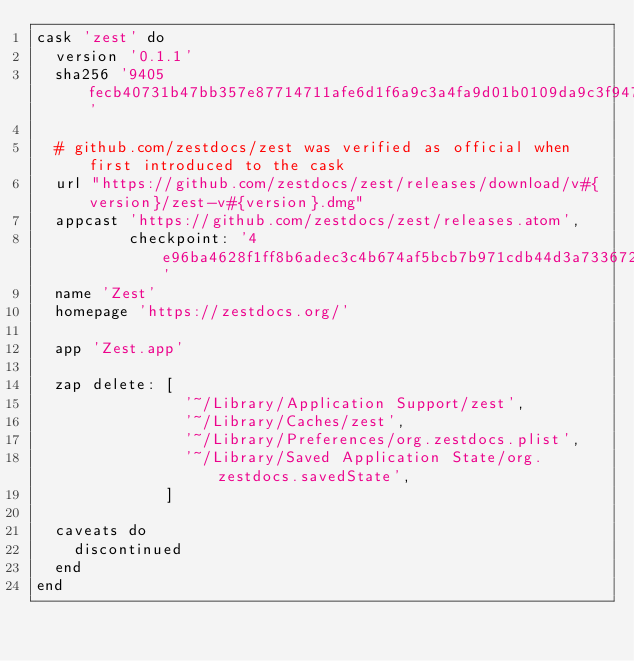Convert code to text. <code><loc_0><loc_0><loc_500><loc_500><_Ruby_>cask 'zest' do
  version '0.1.1'
  sha256 '9405fecb40731b47bb357e87714711afe6d1f6a9c3a4fa9d01b0109da9c3f947'

  # github.com/zestdocs/zest was verified as official when first introduced to the cask
  url "https://github.com/zestdocs/zest/releases/download/v#{version}/zest-v#{version}.dmg"
  appcast 'https://github.com/zestdocs/zest/releases.atom',
          checkpoint: '4e96ba4628f1ff8b6adec3c4b674af5bcb7b971cdb44d3a73367231550a7b221'
  name 'Zest'
  homepage 'https://zestdocs.org/'

  app 'Zest.app'

  zap delete: [
                '~/Library/Application Support/zest',
                '~/Library/Caches/zest',
                '~/Library/Preferences/org.zestdocs.plist',
                '~/Library/Saved Application State/org.zestdocs.savedState',
              ]

  caveats do
    discontinued
  end
end
</code> 